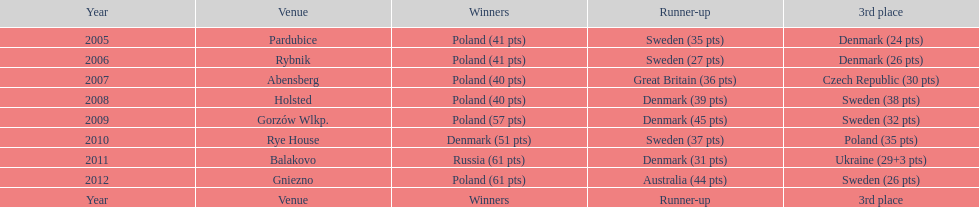Post-2008, what is the total number of points scored by champions? 230. 